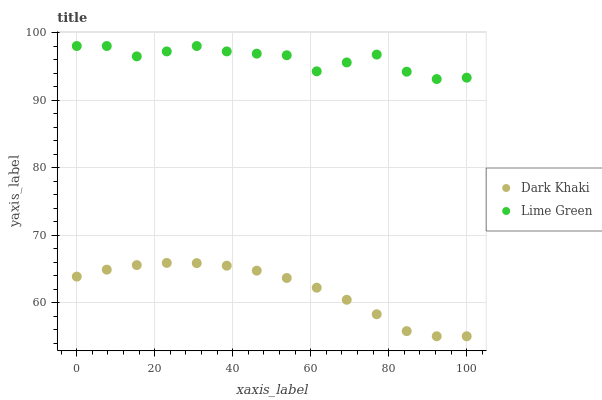Does Dark Khaki have the minimum area under the curve?
Answer yes or no. Yes. Does Lime Green have the maximum area under the curve?
Answer yes or no. Yes. Does Lime Green have the minimum area under the curve?
Answer yes or no. No. Is Dark Khaki the smoothest?
Answer yes or no. Yes. Is Lime Green the roughest?
Answer yes or no. Yes. Is Lime Green the smoothest?
Answer yes or no. No. Does Dark Khaki have the lowest value?
Answer yes or no. Yes. Does Lime Green have the lowest value?
Answer yes or no. No. Does Lime Green have the highest value?
Answer yes or no. Yes. Is Dark Khaki less than Lime Green?
Answer yes or no. Yes. Is Lime Green greater than Dark Khaki?
Answer yes or no. Yes. Does Dark Khaki intersect Lime Green?
Answer yes or no. No. 